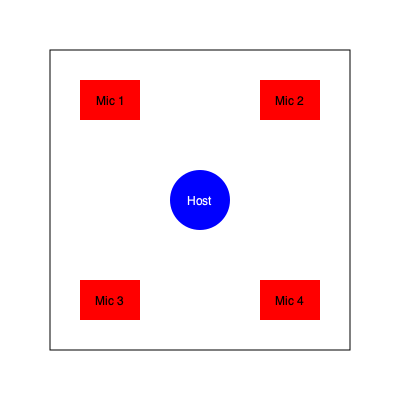In a square podcast studio, the host sits at the center and four guests are positioned at the corners. If the studio measures 6 meters on each side and the host's chair has a diameter of 0.6 meters, what is the shortest distance between the edge of the host's chair and any guest's microphone? Let's approach this step-by-step:

1) The studio is a 6m × 6m square, so the host is at the center point (3m, 3m).

2) The host's chair has a radius of 0.3m (diameter of 0.6m).

3) The guests are at the corners: (0,0), (0,6), (6,0), and (6,6).

4) To find the shortest distance, we need to calculate the distance from the center to a corner and subtract the radius of the chair.

5) The distance from the center to a corner can be calculated using the Pythagorean theorem:
   $$d = \sqrt{(3-0)^2 + (3-0)^2} = \sqrt{18} = 3\sqrt{2}$$

6) Now we subtract the radius of the chair:
   $$3\sqrt{2} - 0.3 = 3\sqrt{2} - 0.3$$

7) This simplifies to approximately 3.94 meters.
Answer: $3\sqrt{2} - 0.3$ meters (≈ 3.94 meters) 